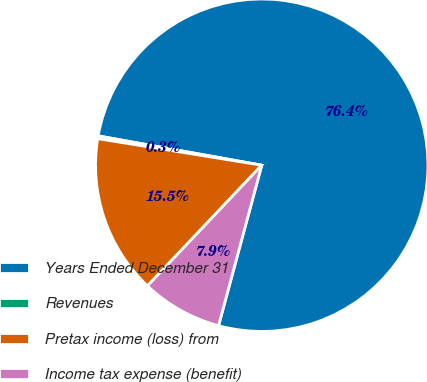Convert chart to OTSL. <chart><loc_0><loc_0><loc_500><loc_500><pie_chart><fcel>Years Ended December 31<fcel>Revenues<fcel>Pretax income (loss) from<fcel>Income tax expense (benefit)<nl><fcel>76.37%<fcel>0.27%<fcel>15.49%<fcel>7.88%<nl></chart> 